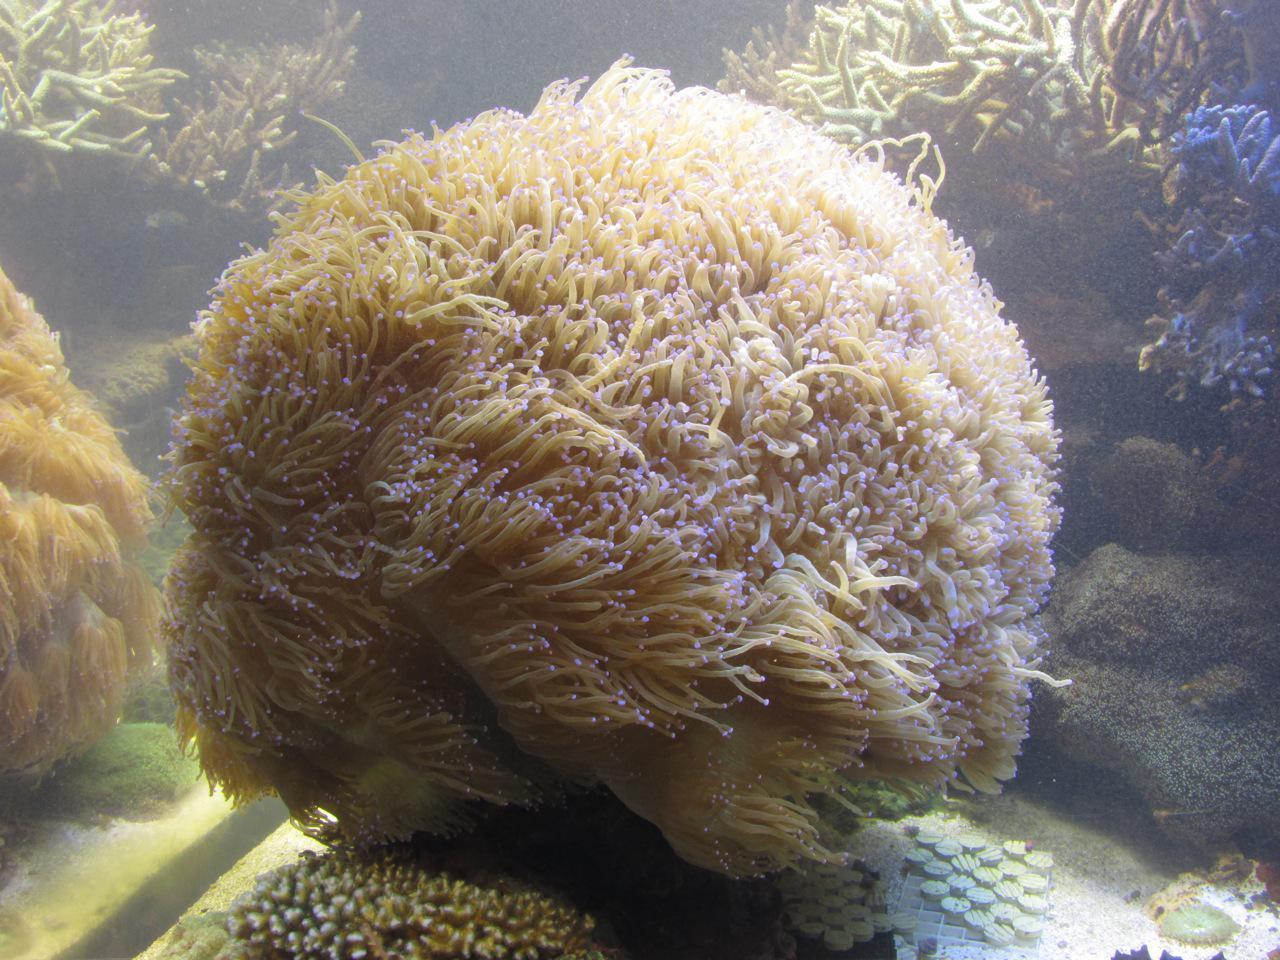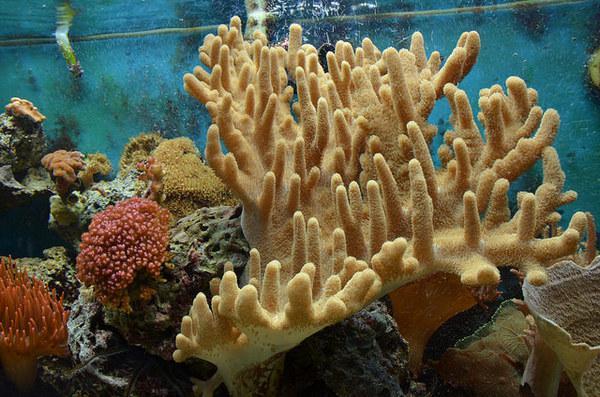The first image is the image on the left, the second image is the image on the right. Considering the images on both sides, is "In at least one image there is a fish with two white stripes and a black belly swimming through a corral." valid? Answer yes or no. No. The first image is the image on the left, the second image is the image on the right. Evaluate the accuracy of this statement regarding the images: "There are two fish total.". Is it true? Answer yes or no. No. 